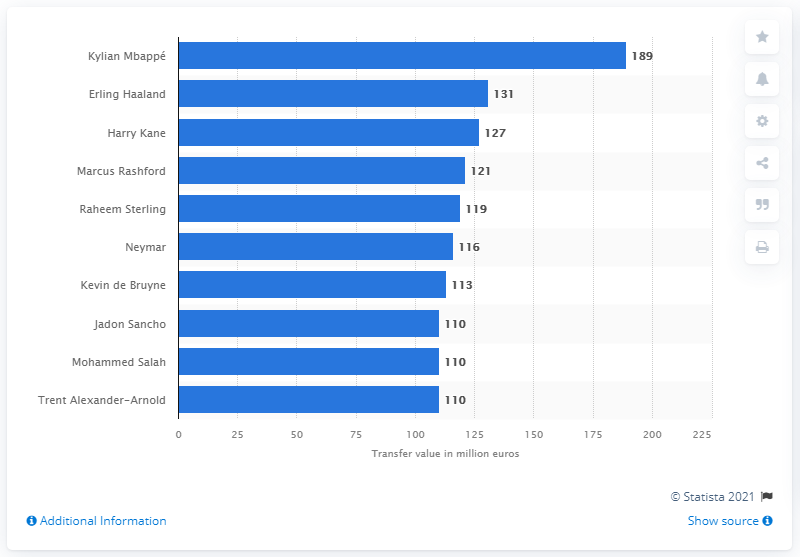Outline some significant characteristics in this image. Erling Haaland is the second most valuable soccer player worldwide. As of April 2021, Mbappa's market value was estimated to be 189 As of April 2021, Haaland's market value was reported to be 131... 